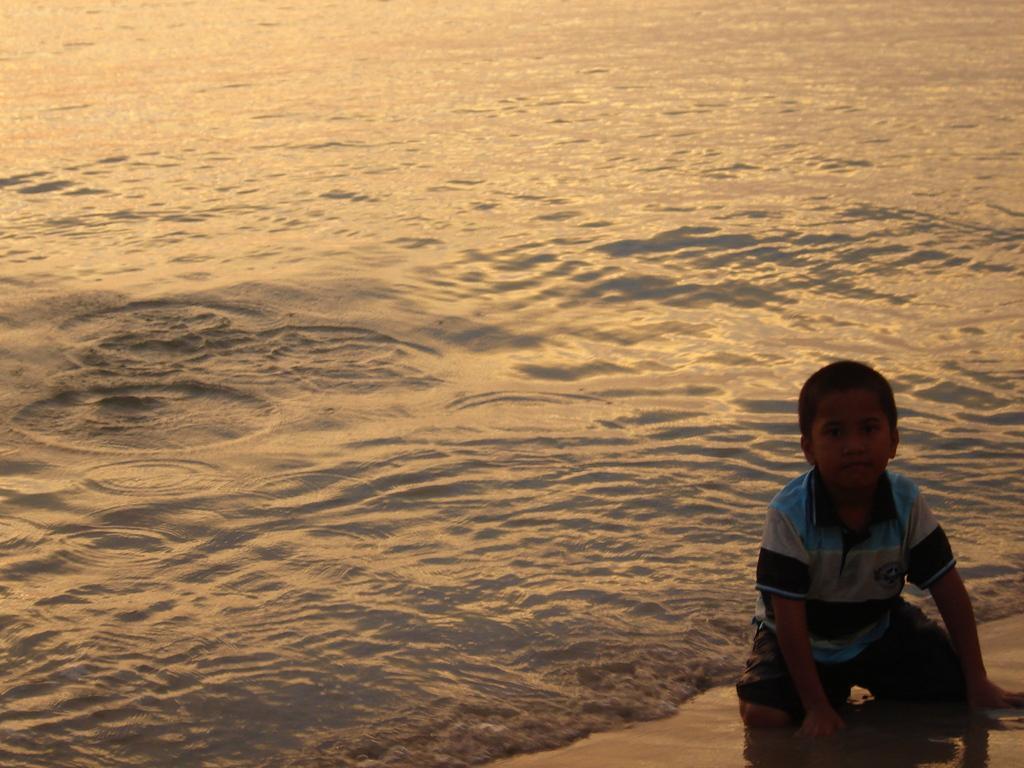Please provide a concise description of this image. In this image on the right side we can see a boy is in crouch position on the sand at the water. 